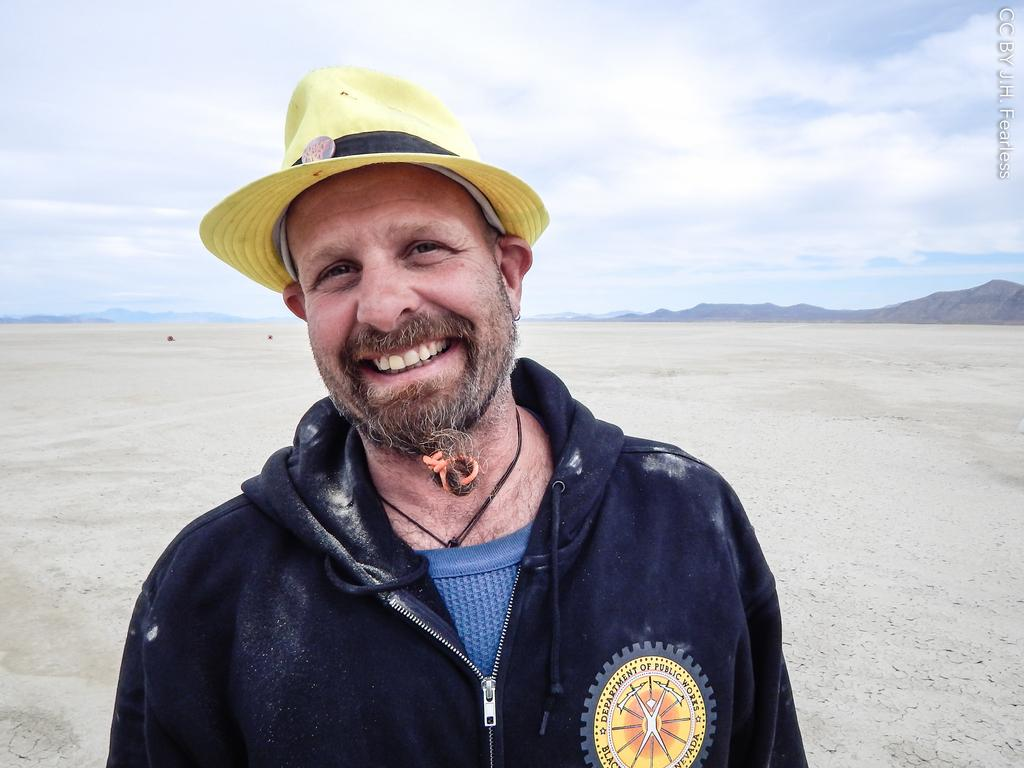Who is present in the image? There is a man in the image. What is the man's facial expression? The man is smiling. What type of landscape can be seen in the image? Hills are visible in the image. What part of the natural environment is visible in the image? The sky is visible in the background of the image. What type of question is being asked by the bears in the image? There are no bears present in the image, so it is not possible to answer that question. 